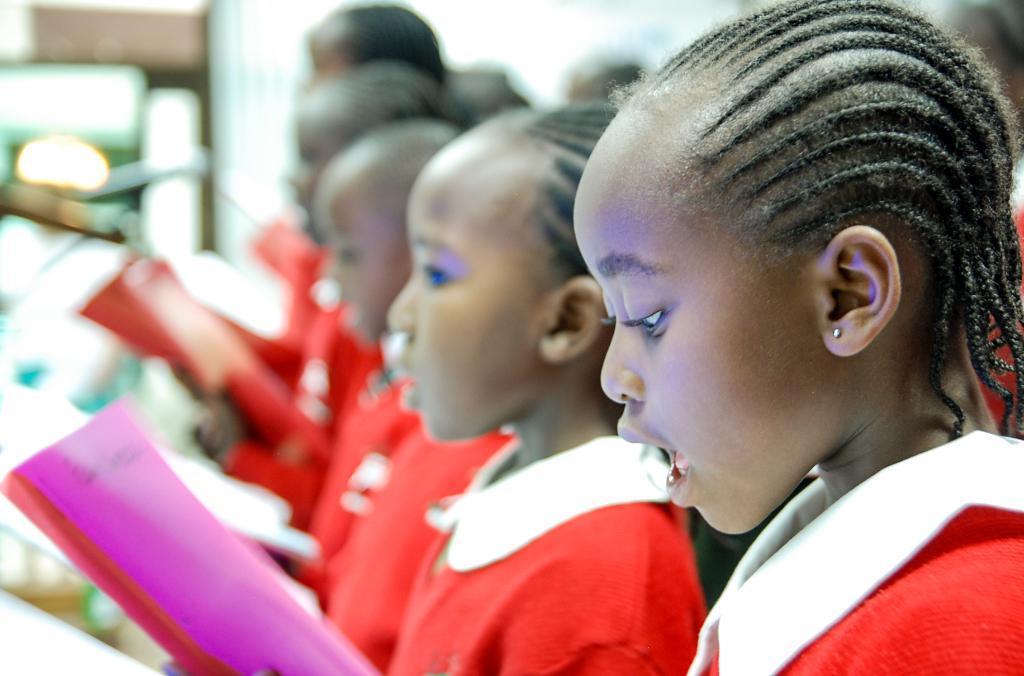Can you describe this image briefly? In this image we can see a group of people and they are holding some objects in their hands. There is a blur background in the image. 